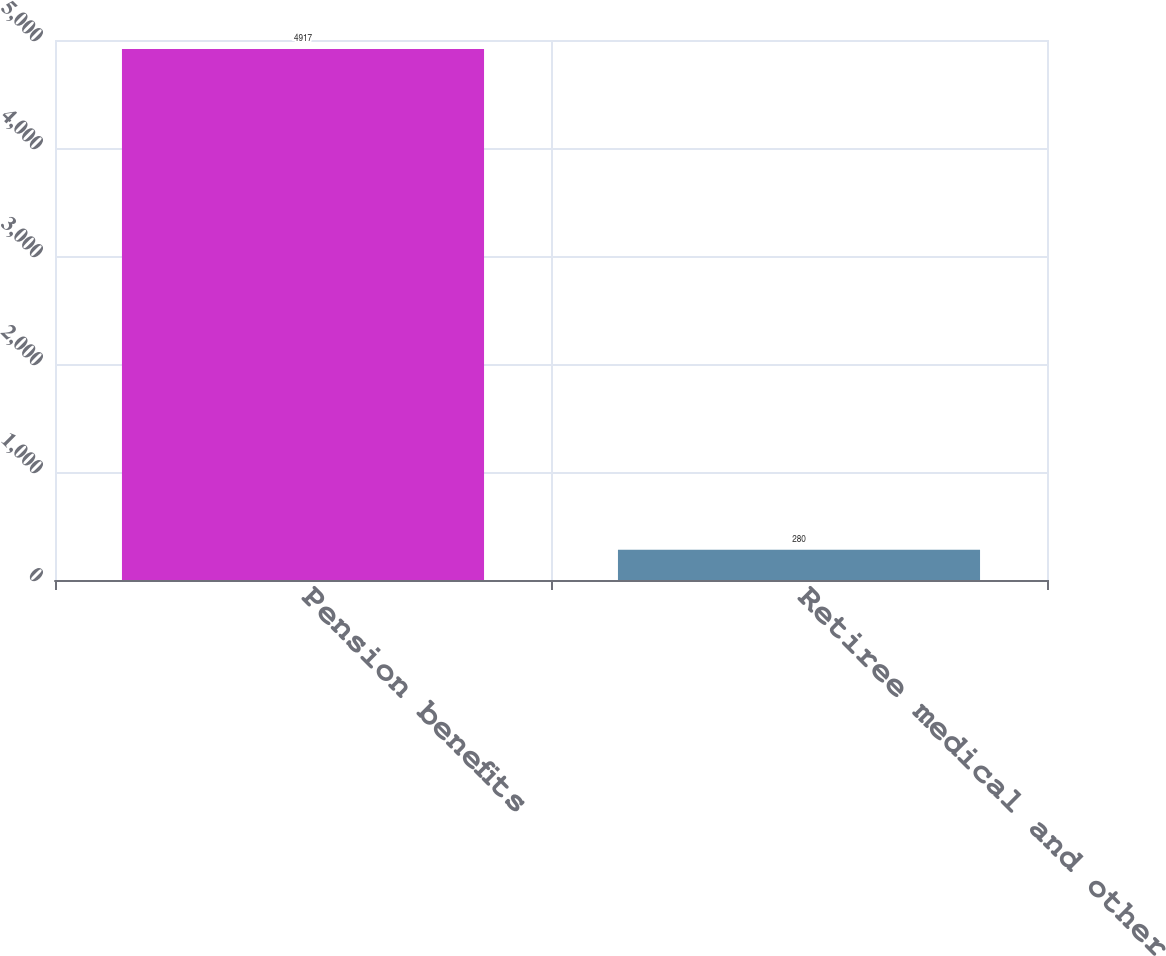Convert chart. <chart><loc_0><loc_0><loc_500><loc_500><bar_chart><fcel>Pension benefits<fcel>Retiree medical and other<nl><fcel>4917<fcel>280<nl></chart> 